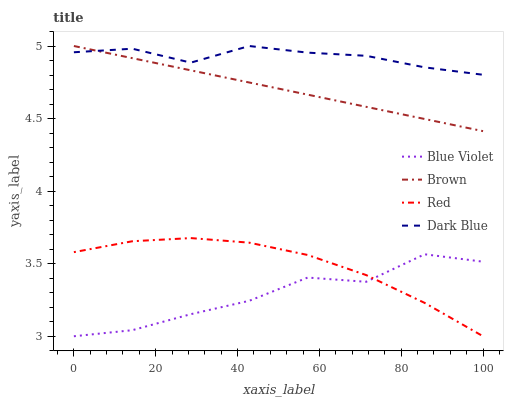Does Red have the minimum area under the curve?
Answer yes or no. No. Does Red have the maximum area under the curve?
Answer yes or no. No. Is Red the smoothest?
Answer yes or no. No. Is Red the roughest?
Answer yes or no. No. Does Dark Blue have the lowest value?
Answer yes or no. No. Does Red have the highest value?
Answer yes or no. No. Is Blue Violet less than Brown?
Answer yes or no. Yes. Is Brown greater than Red?
Answer yes or no. Yes. Does Blue Violet intersect Brown?
Answer yes or no. No. 